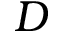Convert formula to latex. <formula><loc_0><loc_0><loc_500><loc_500>D</formula> 